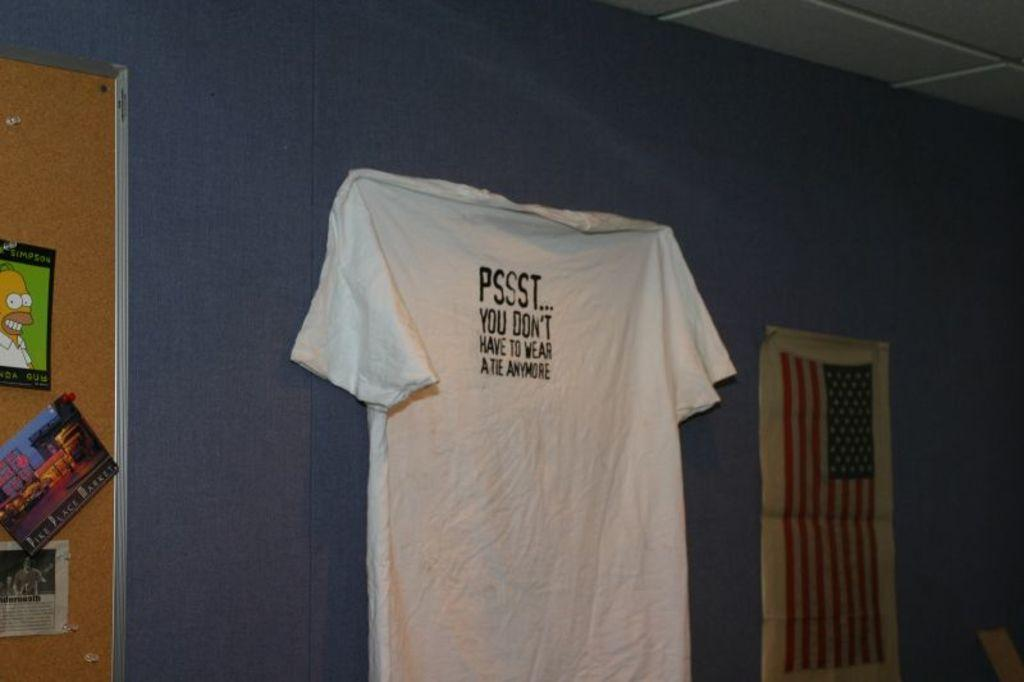<image>
Relay a brief, clear account of the picture shown. A tshirt hanging on the pall that read PSSST... 